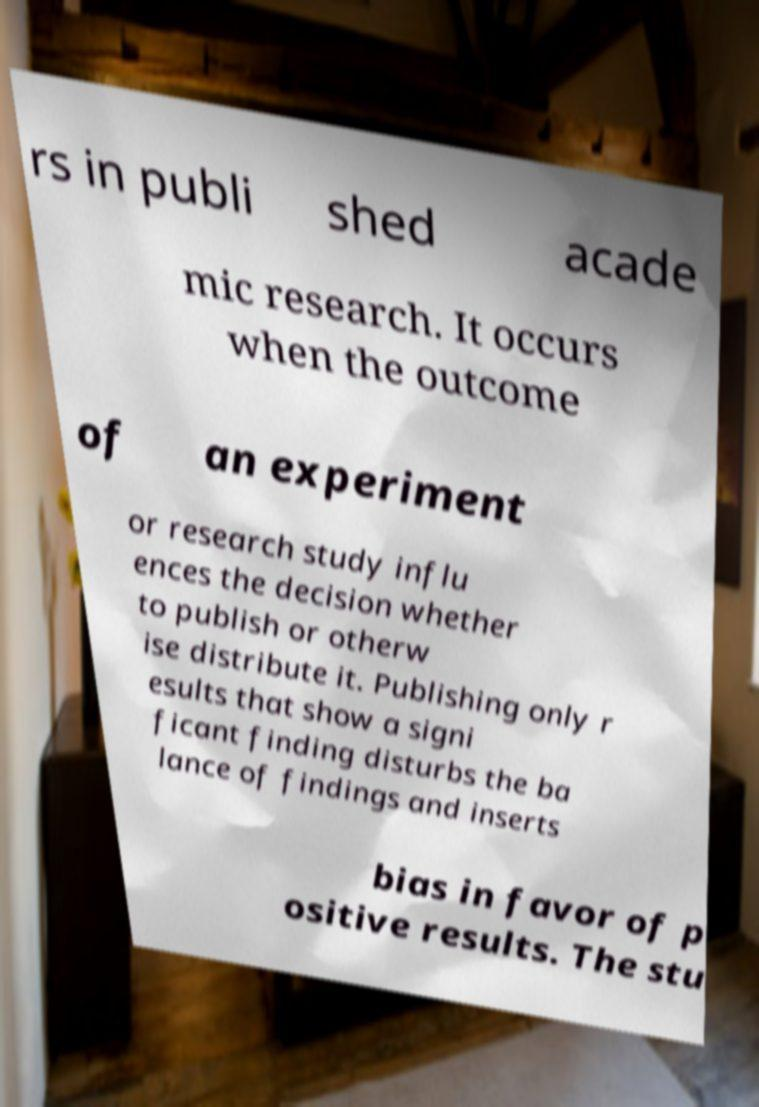I need the written content from this picture converted into text. Can you do that? rs in publi shed acade mic research. It occurs when the outcome of an experiment or research study influ ences the decision whether to publish or otherw ise distribute it. Publishing only r esults that show a signi ficant finding disturbs the ba lance of findings and inserts bias in favor of p ositive results. The stu 